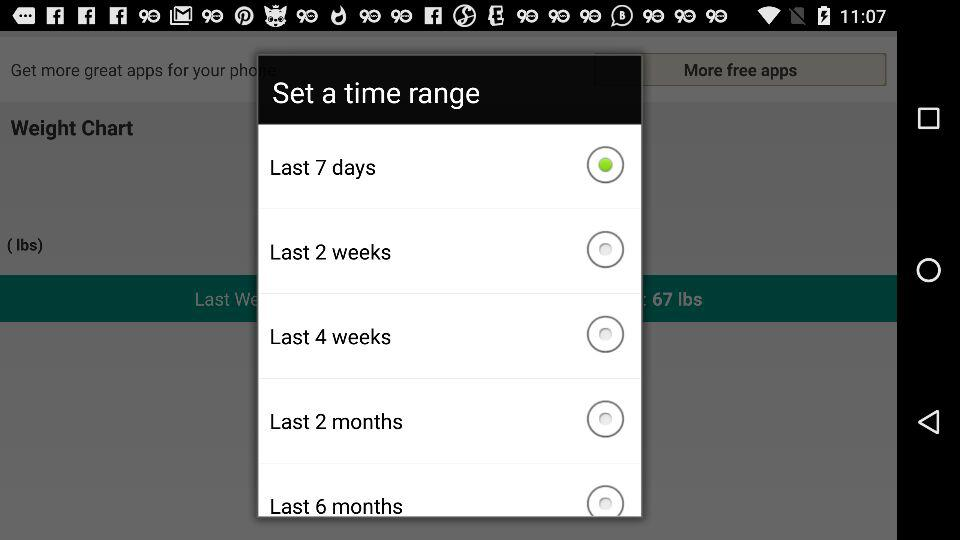How many weeks is the difference between the last 2 weeks and the last 4 weeks?
Answer the question using a single word or phrase. 2 